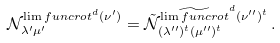Convert formula to latex. <formula><loc_0><loc_0><loc_500><loc_500>\mathcal { N } _ { \lambda ^ { \prime } \mu ^ { \prime } } ^ { \lim f u n c { r o t } ^ { d } ( \nu ^ { \prime } ) } = \mathcal { \tilde { N } } _ { ( \lambda ^ { \prime \prime } ) ^ { t } ( \mu ^ { \prime \prime } ) ^ { t } } ^ { \widetilde { \lim f u n c { r o t } } ^ { d } ( \nu ^ { \prime \prime } ) ^ { t } } \, .</formula> 